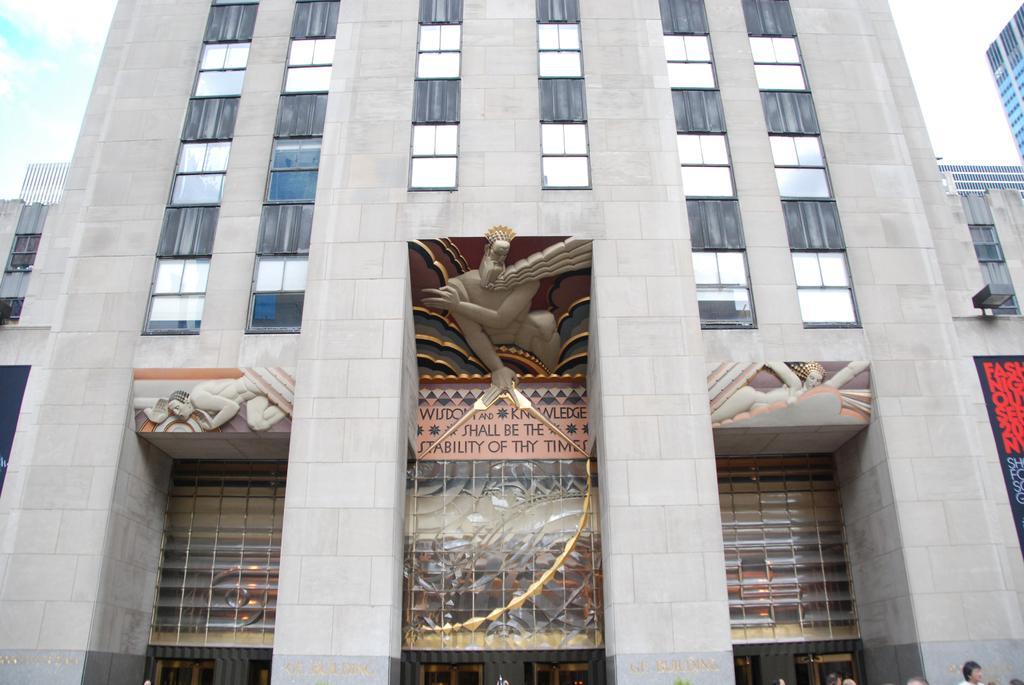What structure is present in the picture? There is a building in the picture. What is located on the building? There is a statue on the building. What is the condition of the sky in the picture? The sky is clear in the picture. What type of coat is the statue wearing in the image? There is no indication of a coat or any clothing on the statue in the image. Can you tell me how many times the statue jumps in the image? The statue is not depicted as jumping or performing any actions in the image. 